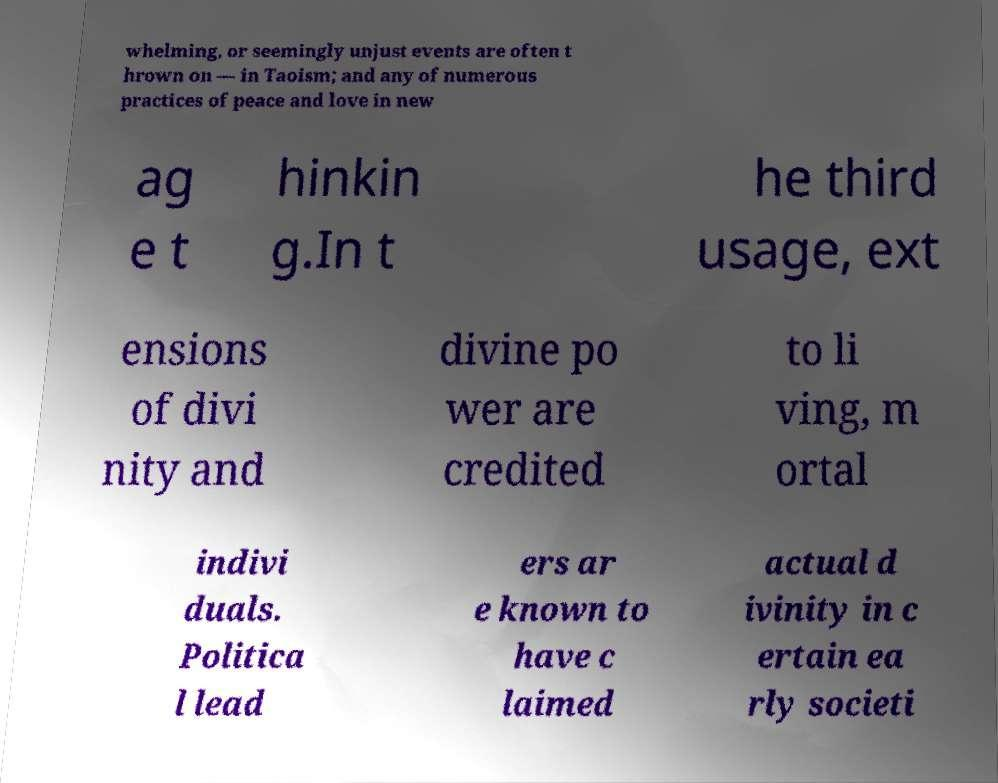Can you read and provide the text displayed in the image?This photo seems to have some interesting text. Can you extract and type it out for me? whelming, or seemingly unjust events are often t hrown on — in Taoism; and any of numerous practices of peace and love in new ag e t hinkin g.In t he third usage, ext ensions of divi nity and divine po wer are credited to li ving, m ortal indivi duals. Politica l lead ers ar e known to have c laimed actual d ivinity in c ertain ea rly societi 